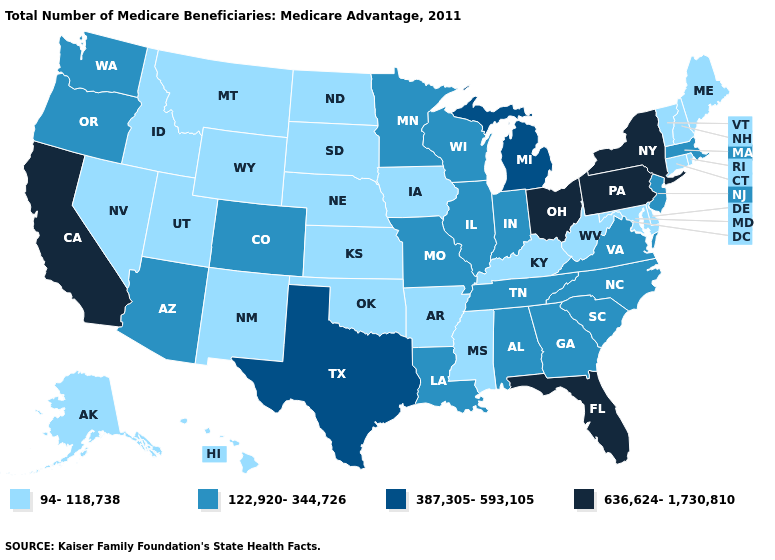What is the value of Delaware?
Write a very short answer. 94-118,738. What is the value of Ohio?
Keep it brief. 636,624-1,730,810. Name the states that have a value in the range 122,920-344,726?
Short answer required. Alabama, Arizona, Colorado, Georgia, Illinois, Indiana, Louisiana, Massachusetts, Minnesota, Missouri, New Jersey, North Carolina, Oregon, South Carolina, Tennessee, Virginia, Washington, Wisconsin. Name the states that have a value in the range 122,920-344,726?
Quick response, please. Alabama, Arizona, Colorado, Georgia, Illinois, Indiana, Louisiana, Massachusetts, Minnesota, Missouri, New Jersey, North Carolina, Oregon, South Carolina, Tennessee, Virginia, Washington, Wisconsin. What is the lowest value in the MidWest?
Short answer required. 94-118,738. Name the states that have a value in the range 387,305-593,105?
Write a very short answer. Michigan, Texas. What is the value of Iowa?
Short answer required. 94-118,738. What is the highest value in the Northeast ?
Give a very brief answer. 636,624-1,730,810. Name the states that have a value in the range 636,624-1,730,810?
Be succinct. California, Florida, New York, Ohio, Pennsylvania. What is the lowest value in the USA?
Be succinct. 94-118,738. What is the lowest value in the MidWest?
Answer briefly. 94-118,738. What is the highest value in the Northeast ?
Short answer required. 636,624-1,730,810. What is the value of Iowa?
Be succinct. 94-118,738. What is the value of North Carolina?
Answer briefly. 122,920-344,726. What is the value of Florida?
Quick response, please. 636,624-1,730,810. 